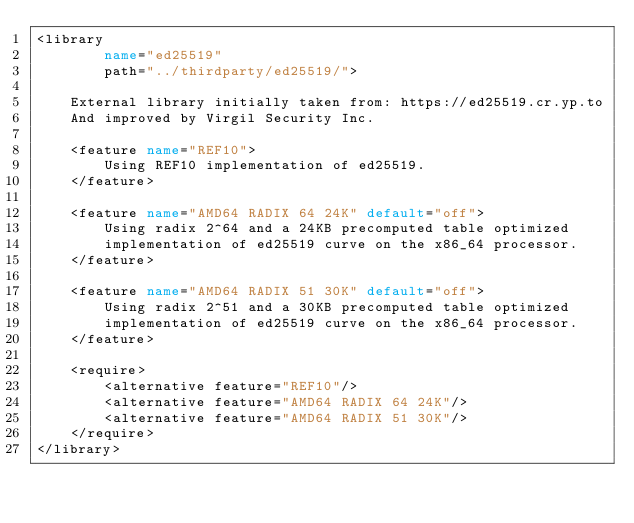Convert code to text. <code><loc_0><loc_0><loc_500><loc_500><_XML_><library
        name="ed25519"
        path="../thirdparty/ed25519/">

    External library initially taken from: https://ed25519.cr.yp.to
    And improved by Virgil Security Inc.

    <feature name="REF10">
        Using REF10 implementation of ed25519.
    </feature>

    <feature name="AMD64 RADIX 64 24K" default="off">
        Using radix 2^64 and a 24KB precomputed table optimized
        implementation of ed25519 curve on the x86_64 processor.
    </feature>

    <feature name="AMD64 RADIX 51 30K" default="off">
        Using radix 2^51 and a 30KB precomputed table optimized
        implementation of ed25519 curve on the x86_64 processor.
    </feature>

    <require>
        <alternative feature="REF10"/>
        <alternative feature="AMD64 RADIX 64 24K"/>
        <alternative feature="AMD64 RADIX 51 30K"/>
    </require>
</library>
</code> 